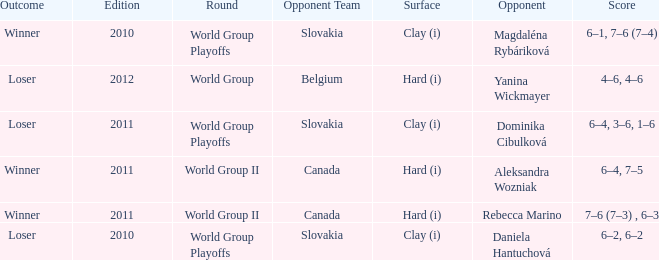What was the game edition when they played on the clay (i) surface and the outcome was a winner? 2010.0. 